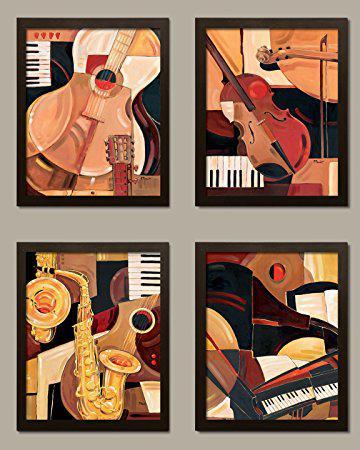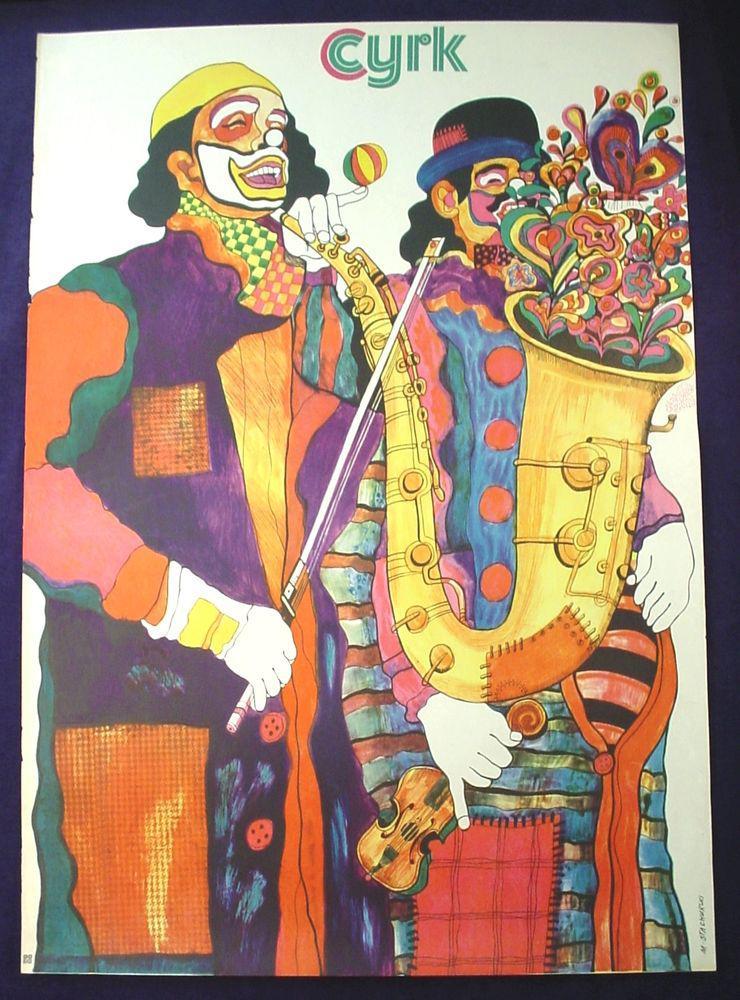The first image is the image on the left, the second image is the image on the right. Given the left and right images, does the statement "One of the drawings depicts a dog." hold true? Answer yes or no. No. The first image is the image on the left, the second image is the image on the right. For the images shown, is this caption "One image shows four art renderings of musical instruments, including saxophone, violin and keyboard, and the other image depicts a person standing and playing a saxophone." true? Answer yes or no. Yes. 